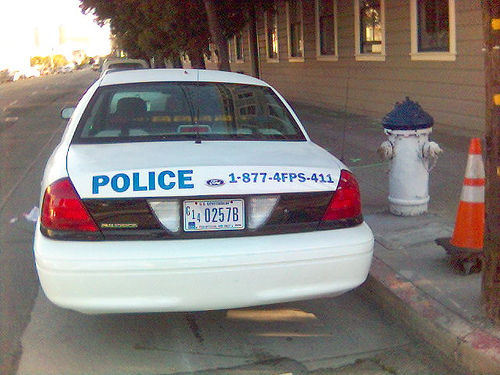<image>What state police is this? It is ambiguous to tell which state police this is. It could be one of several states including Connecticut, Alabama, New York, Louisiana, Michigan, Washington or California. What state police is this? It is ambiguous which state police this is. It could be Connecticut, Alabama, New York, Louisiana, Michigan, Washington, or California. 